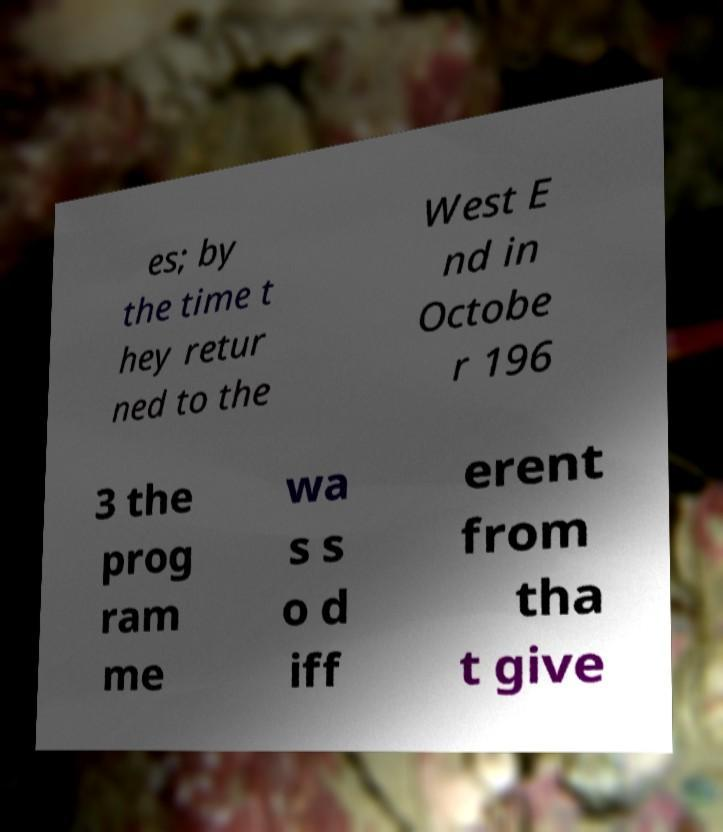Can you accurately transcribe the text from the provided image for me? es; by the time t hey retur ned to the West E nd in Octobe r 196 3 the prog ram me wa s s o d iff erent from tha t give 